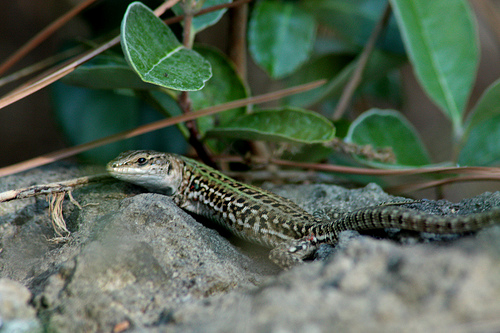<image>
Is the stone behind the lizard? No. The stone is not behind the lizard. From this viewpoint, the stone appears to be positioned elsewhere in the scene. Where is the lizard in relation to the tree? Is it behind the tree? No. The lizard is not behind the tree. From this viewpoint, the lizard appears to be positioned elsewhere in the scene. 